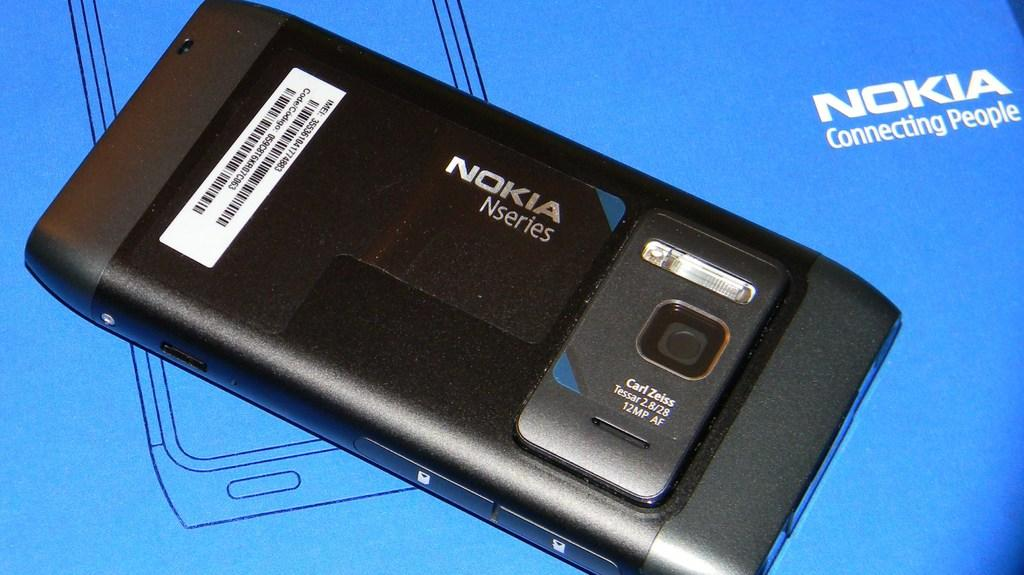<image>
Share a concise interpretation of the image provided. A black Nokia N series brand phone on a blue box 